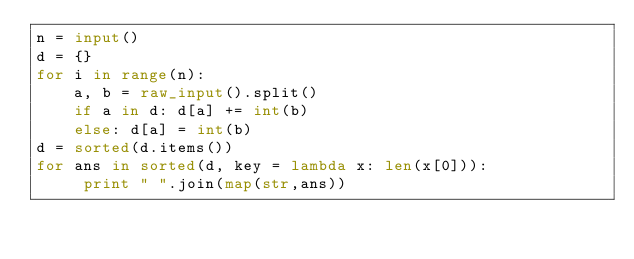<code> <loc_0><loc_0><loc_500><loc_500><_Python_>n = input()
d = {}
for i in range(n):
    a, b = raw_input().split()
    if a in d: d[a] += int(b)
    else: d[a] = int(b)
d = sorted(d.items())
for ans in sorted(d, key = lambda x: len(x[0])):
     print " ".join(map(str,ans))</code> 